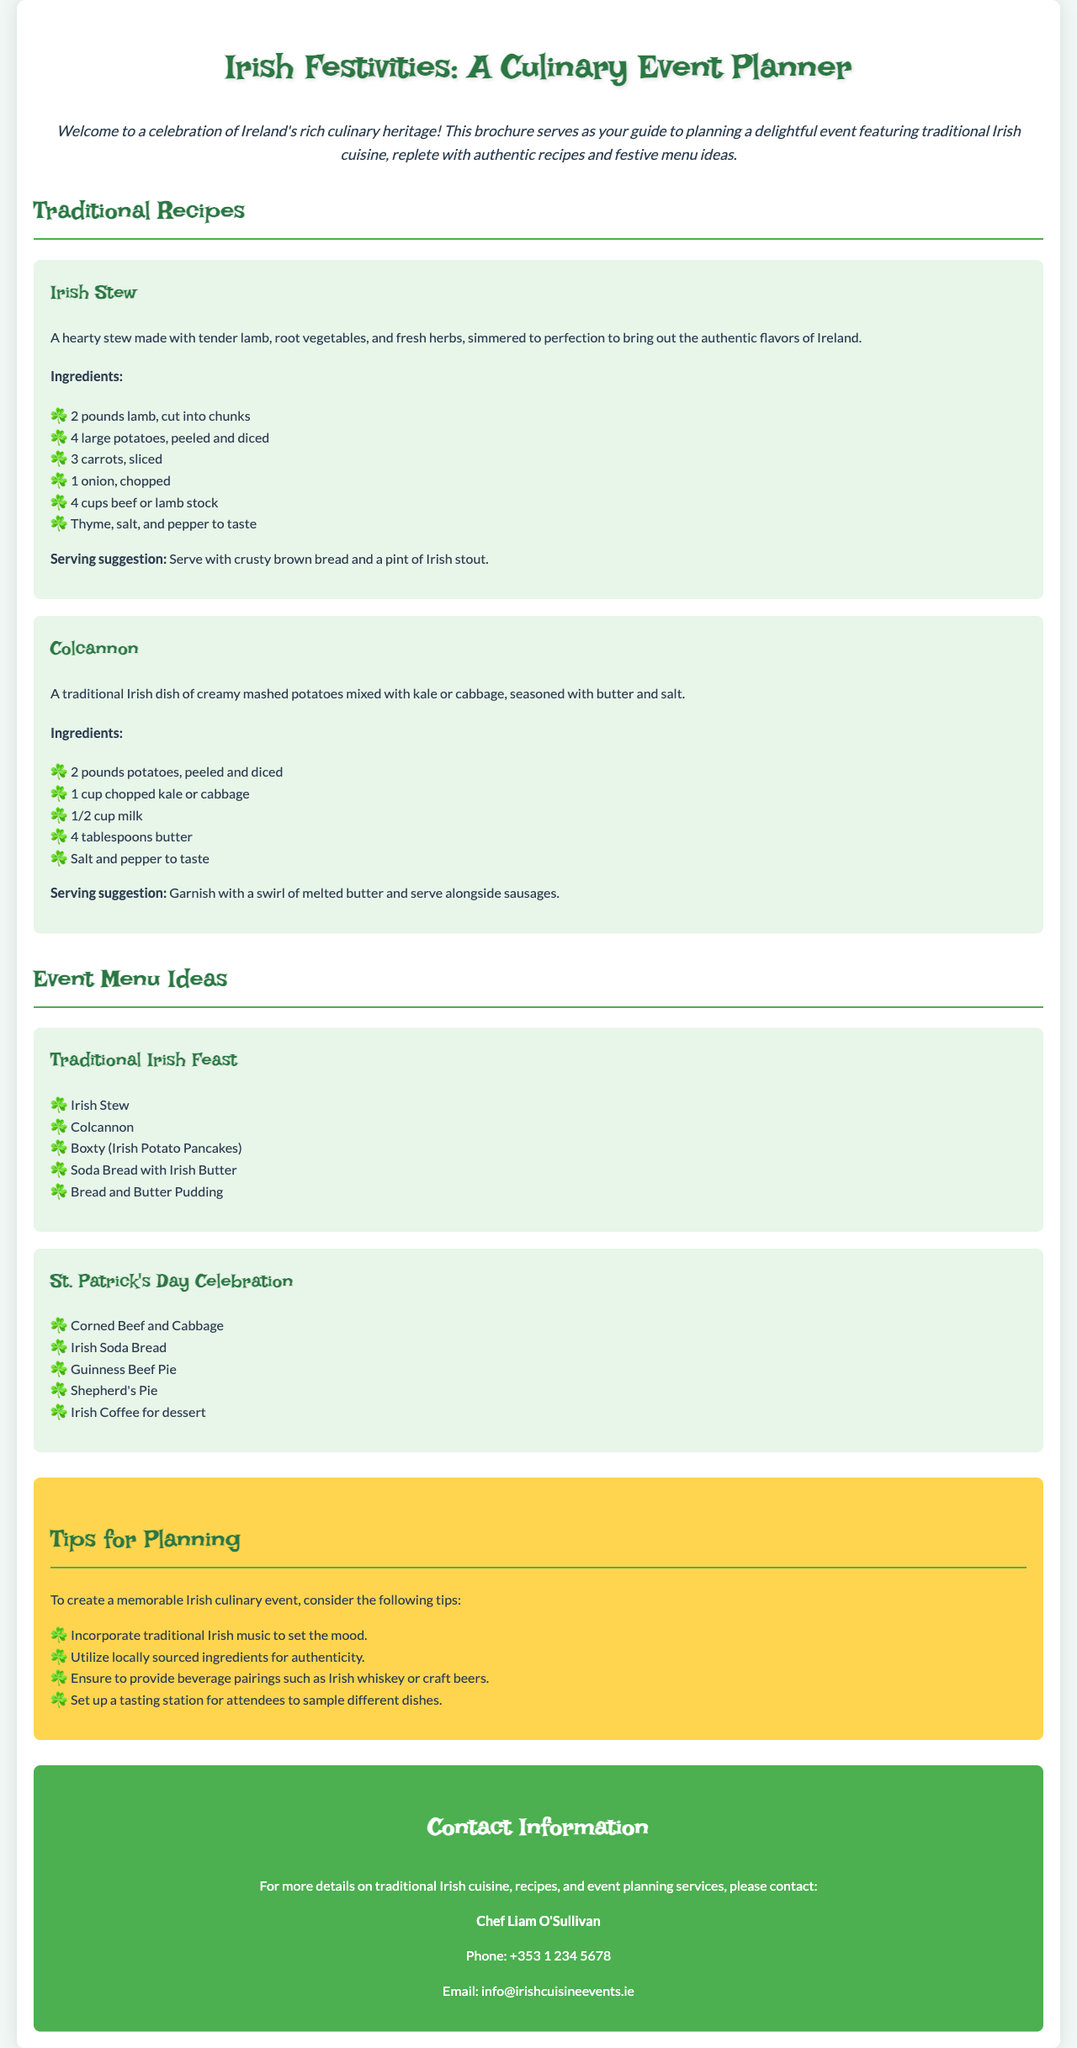What is the title of the brochure? The title is prominently displayed at the top of the document.
Answer: Irish Festivities: A Culinary Event Planner Who is the contact person for more details? The contact section specifies the name of the individual to reach for further information.
Answer: Chef Liam O'Sullivan What is a key ingredient in Irish Stew? The recipe section lists several ingredients for Irish Stew.
Answer: Lamb What is the serving suggestion for Colcannon? The recipe section suggests a specific way to serve Colcannon.
Answer: Garnish with a swirl of melted butter and serve alongside sausages How many items are listed in the Traditional Irish Feast menu? The menu section enumerates the dishes in the Traditional Irish Feast.
Answer: Five What beverage pairings are suggested? The tips section provides recommendations for beverages to complement the food.
Answer: Irish whiskey or craft beers What ingredients are needed for Colcannon? The recipe section outlines the ingredients required for making Colcannon.
Answer: Potatoes, kale or cabbage, milk, butter, salt, and pepper What type of music is suggested for the event? The tips section emphasizes the mood-enhancing aspect of music at the event.
Answer: Traditional Irish music What is mentioned as an ingredient for the St. Patrick's Day Celebration menu? The menu specifies ingredients for one of the dishes listed.
Answer: Corned Beef and Cabbage 